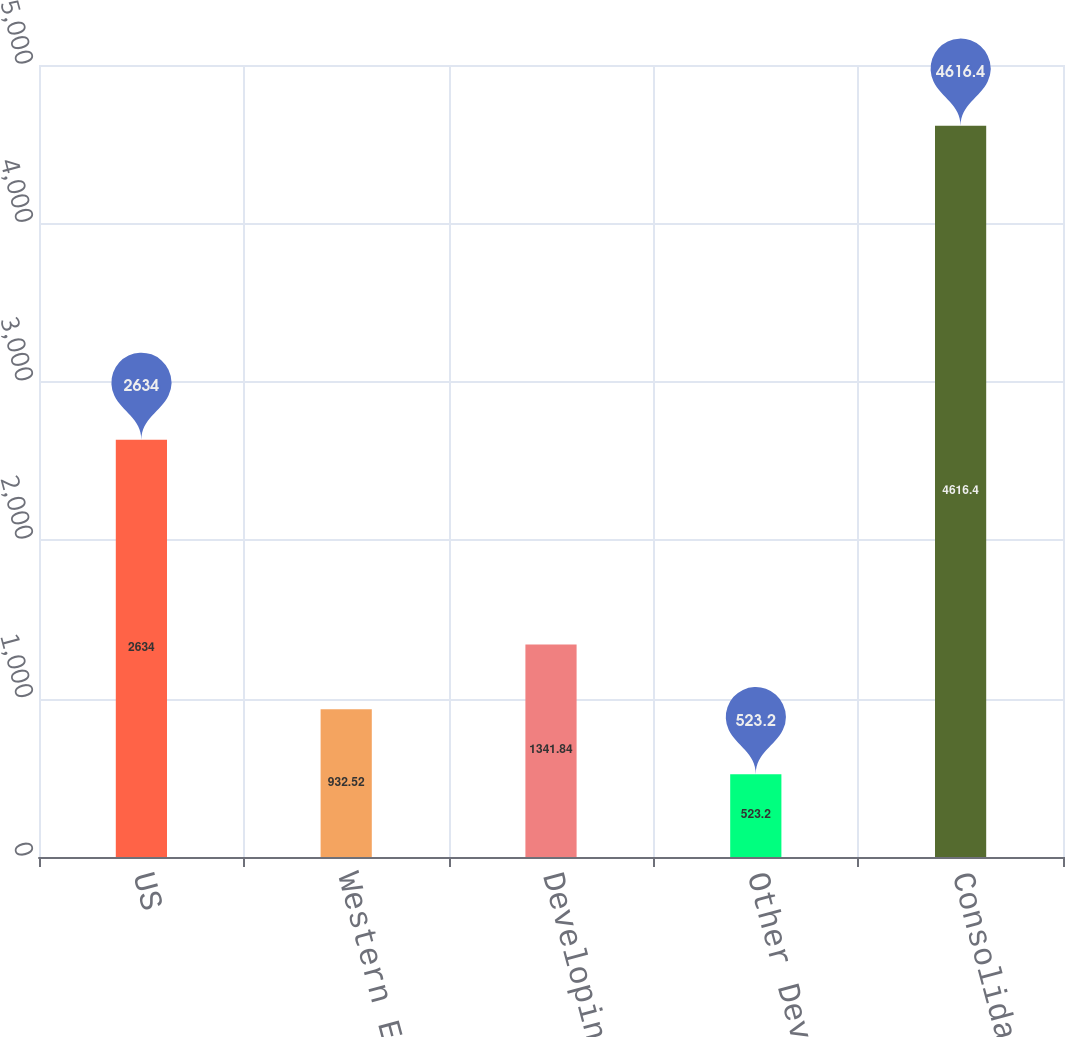Convert chart. <chart><loc_0><loc_0><loc_500><loc_500><bar_chart><fcel>US<fcel>Western Europe<fcel>Developing (1)<fcel>Other Developed (2)<fcel>Consolidated<nl><fcel>2634<fcel>932.52<fcel>1341.84<fcel>523.2<fcel>4616.4<nl></chart> 